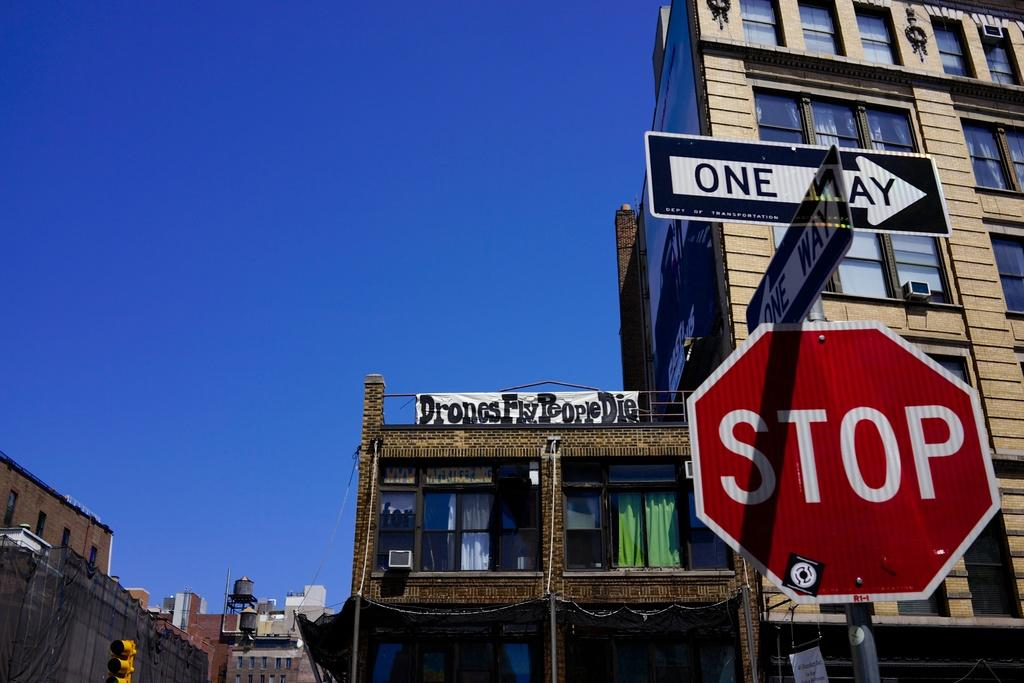Provide a one-sentence caption for the provided image. Two one-way signs mounted on top of a stop sign. 